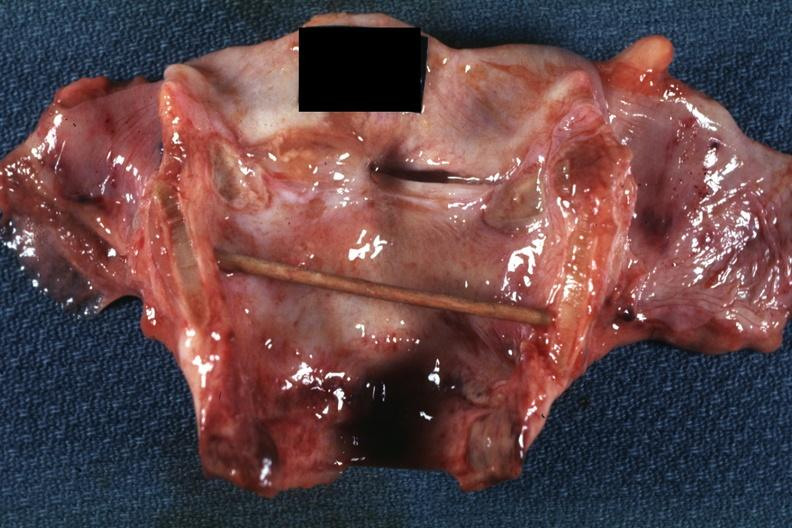s metastatic malignant melanoma present?
Answer the question using a single word or phrase. No 